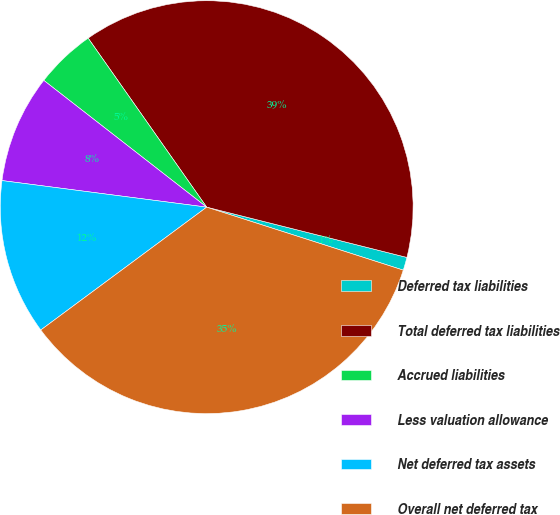<chart> <loc_0><loc_0><loc_500><loc_500><pie_chart><fcel>Deferred tax liabilities<fcel>Total deferred tax liabilities<fcel>Accrued liabilities<fcel>Less valuation allowance<fcel>Net deferred tax assets<fcel>Overall net deferred tax<nl><fcel>1.02%<fcel>38.65%<fcel>4.74%<fcel>8.47%<fcel>12.2%<fcel>34.92%<nl></chart> 